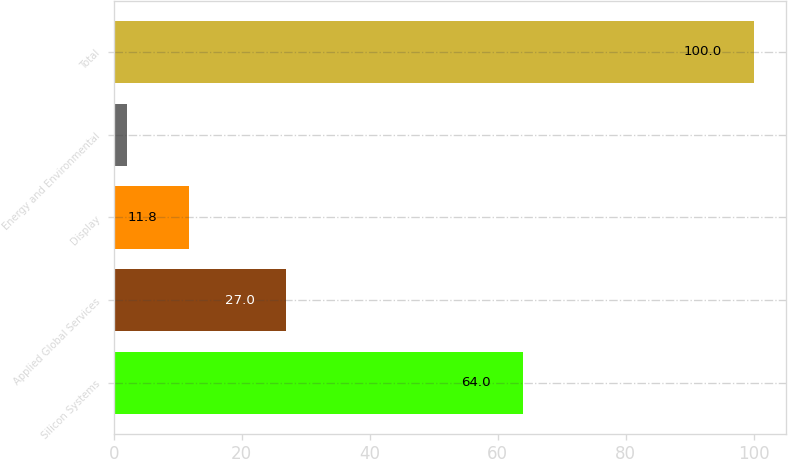Convert chart. <chart><loc_0><loc_0><loc_500><loc_500><bar_chart><fcel>Silicon Systems<fcel>Applied Global Services<fcel>Display<fcel>Energy and Environmental<fcel>Total<nl><fcel>64<fcel>27<fcel>11.8<fcel>2<fcel>100<nl></chart> 